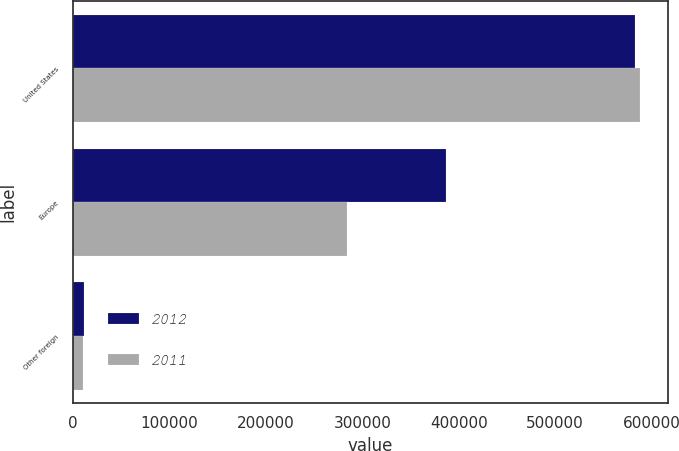Convert chart. <chart><loc_0><loc_0><loc_500><loc_500><stacked_bar_chart><ecel><fcel>United States<fcel>Europe<fcel>Other foreign<nl><fcel>2012<fcel>582387<fcel>386871<fcel>10778<nl><fcel>2011<fcel>587592<fcel>284171<fcel>9627<nl></chart> 